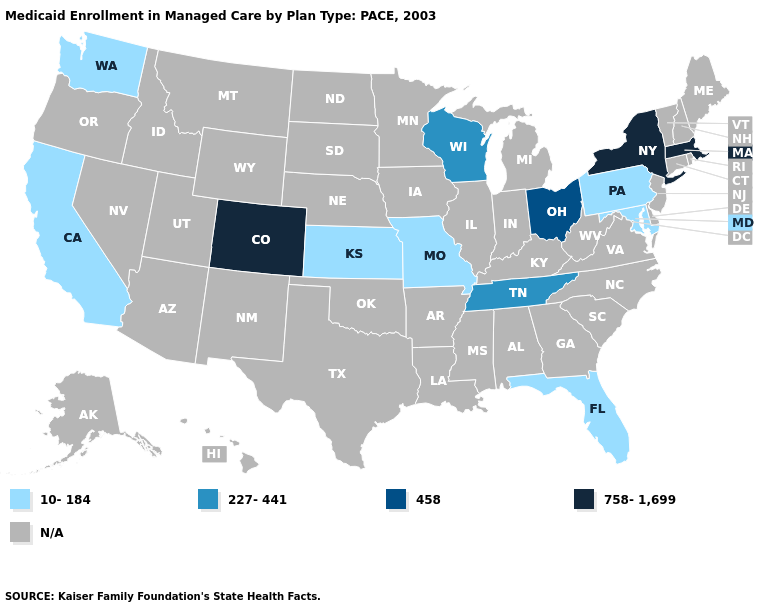Does Florida have the highest value in the USA?
Quick response, please. No. Which states hav the highest value in the Northeast?
Keep it brief. Massachusetts, New York. Does Kansas have the highest value in the MidWest?
Keep it brief. No. Does the map have missing data?
Concise answer only. Yes. Which states have the lowest value in the USA?
Answer briefly. California, Florida, Kansas, Maryland, Missouri, Pennsylvania, Washington. Name the states that have a value in the range N/A?
Be succinct. Alabama, Alaska, Arizona, Arkansas, Connecticut, Delaware, Georgia, Hawaii, Idaho, Illinois, Indiana, Iowa, Kentucky, Louisiana, Maine, Michigan, Minnesota, Mississippi, Montana, Nebraska, Nevada, New Hampshire, New Jersey, New Mexico, North Carolina, North Dakota, Oklahoma, Oregon, Rhode Island, South Carolina, South Dakota, Texas, Utah, Vermont, Virginia, West Virginia, Wyoming. Is the legend a continuous bar?
Quick response, please. No. What is the value of Wisconsin?
Give a very brief answer. 227-441. Does the map have missing data?
Be succinct. Yes. Does Tennessee have the highest value in the South?
Keep it brief. Yes. Does the map have missing data?
Give a very brief answer. Yes. What is the value of Georgia?
Give a very brief answer. N/A. Name the states that have a value in the range 458?
Quick response, please. Ohio. What is the lowest value in states that border North Carolina?
Write a very short answer. 227-441. Which states have the lowest value in the West?
Be succinct. California, Washington. 